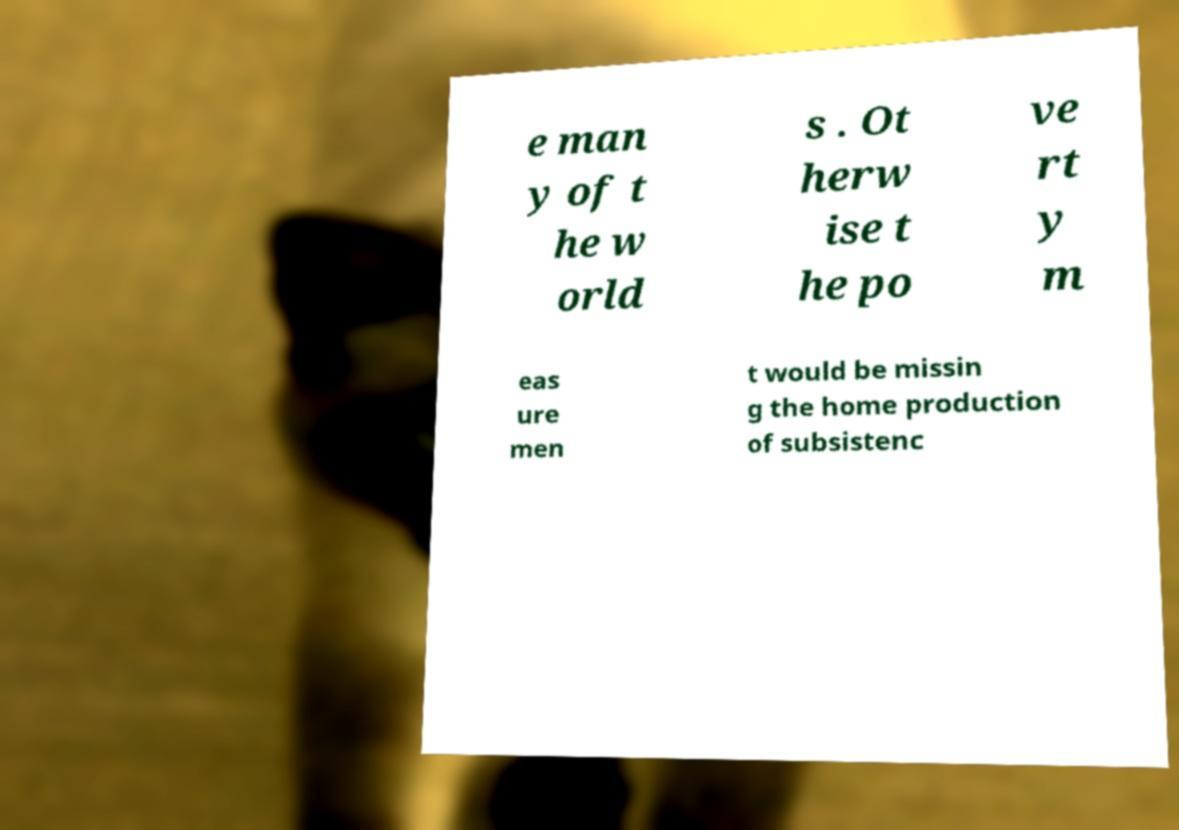For documentation purposes, I need the text within this image transcribed. Could you provide that? e man y of t he w orld s . Ot herw ise t he po ve rt y m eas ure men t would be missin g the home production of subsistenc 